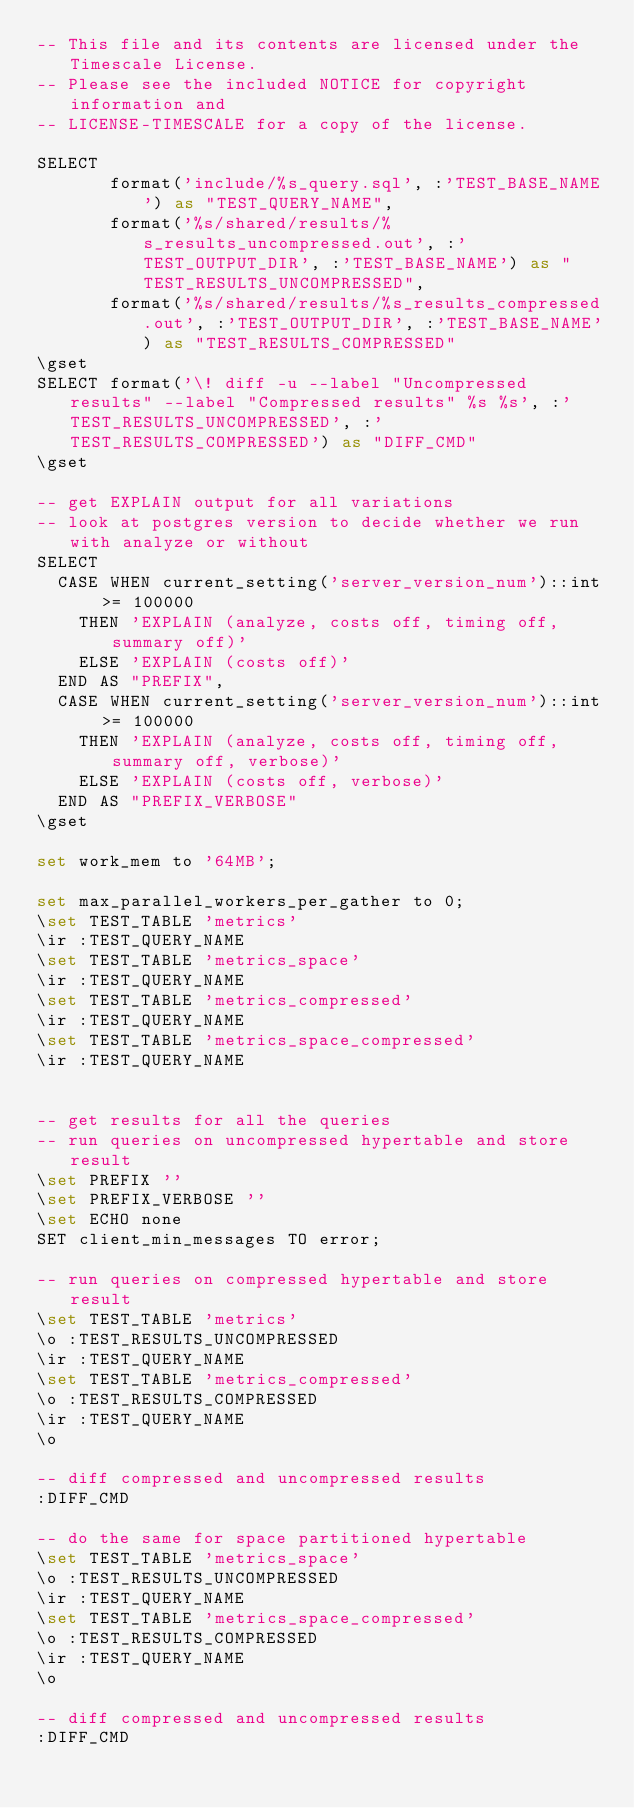<code> <loc_0><loc_0><loc_500><loc_500><_SQL_>-- This file and its contents are licensed under the Timescale License.
-- Please see the included NOTICE for copyright information and
-- LICENSE-TIMESCALE for a copy of the license.

SELECT
       format('include/%s_query.sql', :'TEST_BASE_NAME') as "TEST_QUERY_NAME",
       format('%s/shared/results/%s_results_uncompressed.out', :'TEST_OUTPUT_DIR', :'TEST_BASE_NAME') as "TEST_RESULTS_UNCOMPRESSED",
       format('%s/shared/results/%s_results_compressed.out', :'TEST_OUTPUT_DIR', :'TEST_BASE_NAME') as "TEST_RESULTS_COMPRESSED"
\gset
SELECT format('\! diff -u --label "Uncompressed results" --label "Compressed results" %s %s', :'TEST_RESULTS_UNCOMPRESSED', :'TEST_RESULTS_COMPRESSED') as "DIFF_CMD"
\gset

-- get EXPLAIN output for all variations
-- look at postgres version to decide whether we run with analyze or without
SELECT
  CASE WHEN current_setting('server_version_num')::int >= 100000
    THEN 'EXPLAIN (analyze, costs off, timing off, summary off)'
    ELSE 'EXPLAIN (costs off)'
  END AS "PREFIX",
  CASE WHEN current_setting('server_version_num')::int >= 100000
    THEN 'EXPLAIN (analyze, costs off, timing off, summary off, verbose)'
    ELSE 'EXPLAIN (costs off, verbose)'
  END AS "PREFIX_VERBOSE"
\gset

set work_mem to '64MB';

set max_parallel_workers_per_gather to 0;
\set TEST_TABLE 'metrics'
\ir :TEST_QUERY_NAME
\set TEST_TABLE 'metrics_space'
\ir :TEST_QUERY_NAME
\set TEST_TABLE 'metrics_compressed'
\ir :TEST_QUERY_NAME
\set TEST_TABLE 'metrics_space_compressed'
\ir :TEST_QUERY_NAME


-- get results for all the queries
-- run queries on uncompressed hypertable and store result
\set PREFIX ''
\set PREFIX_VERBOSE ''
\set ECHO none
SET client_min_messages TO error;

-- run queries on compressed hypertable and store result
\set TEST_TABLE 'metrics'
\o :TEST_RESULTS_UNCOMPRESSED
\ir :TEST_QUERY_NAME
\set TEST_TABLE 'metrics_compressed'
\o :TEST_RESULTS_COMPRESSED
\ir :TEST_QUERY_NAME
\o

-- diff compressed and uncompressed results
:DIFF_CMD

-- do the same for space partitioned hypertable
\set TEST_TABLE 'metrics_space'
\o :TEST_RESULTS_UNCOMPRESSED
\ir :TEST_QUERY_NAME
\set TEST_TABLE 'metrics_space_compressed'
\o :TEST_RESULTS_COMPRESSED
\ir :TEST_QUERY_NAME
\o

-- diff compressed and uncompressed results
:DIFF_CMD
</code> 